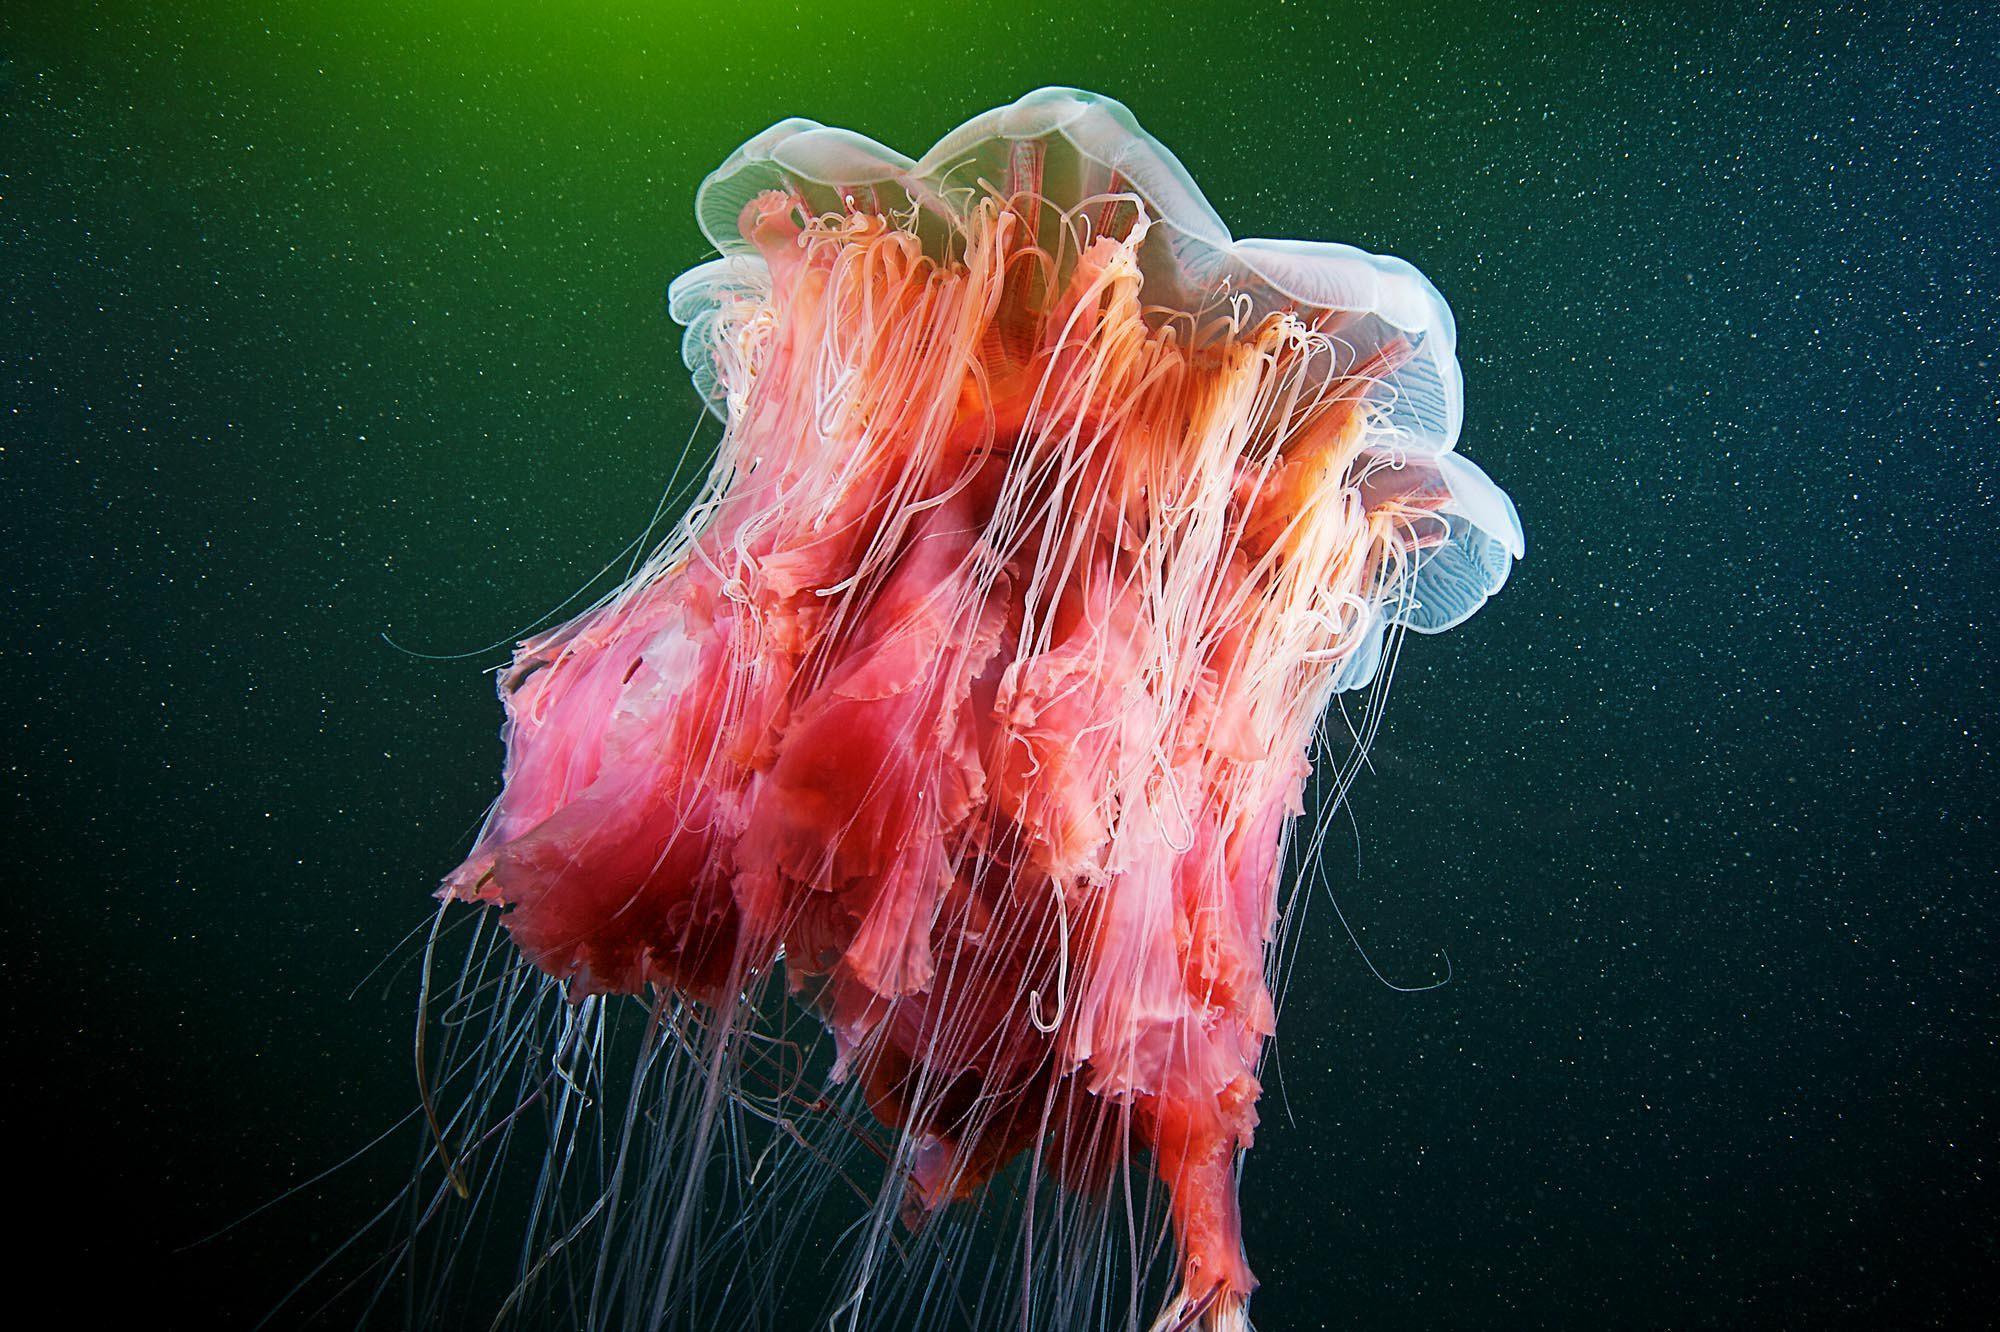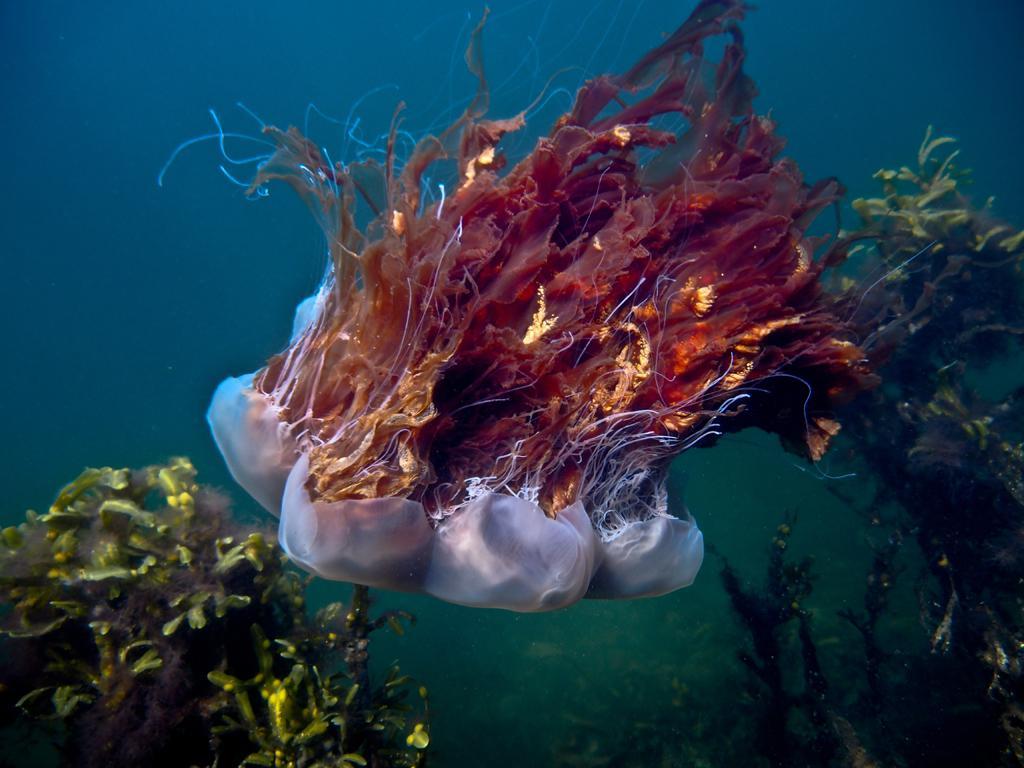The first image is the image on the left, the second image is the image on the right. Considering the images on both sides, is "Each image includes a jellyfish with multiple threadlike tentacles, and each jellyfish image has a blue-green multi-tone background." valid? Answer yes or no. Yes. The first image is the image on the left, the second image is the image on the right. Evaluate the accuracy of this statement regarding the images: "In at least one of the images, there is greenish light coming through the water above the jellyfish.". Is it true? Answer yes or no. Yes. 